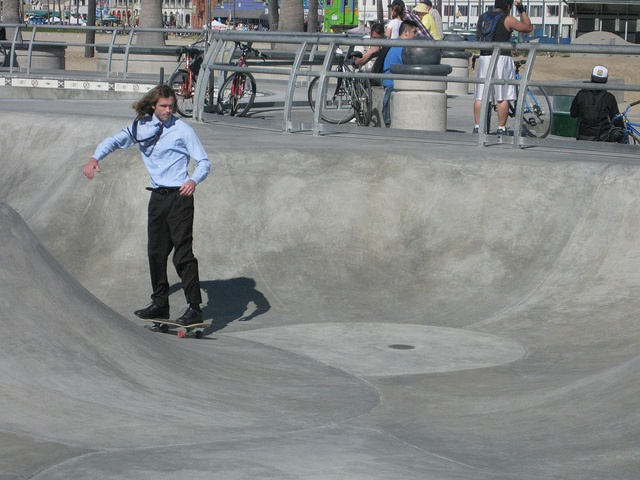Describe the objects in this image and their specific colors. I can see people in gray, black, lavender, and darkgray tones, bicycle in gray, darkgray, and black tones, people in gray, black, darkgray, and lightgray tones, people in gray, black, lightgray, and darkgray tones, and bicycle in gray, darkgray, and black tones in this image. 